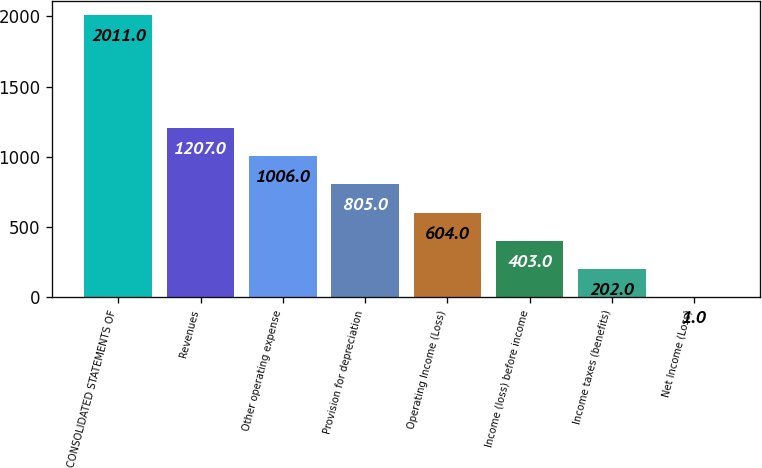Convert chart to OTSL. <chart><loc_0><loc_0><loc_500><loc_500><bar_chart><fcel>CONSOLIDATED STATEMENTS OF<fcel>Revenues<fcel>Other operating expense<fcel>Provision for depreciation<fcel>Operating Income (Loss)<fcel>Income (loss) before income<fcel>Income taxes (benefits)<fcel>Net Income (Loss)<nl><fcel>2011<fcel>1207<fcel>1006<fcel>805<fcel>604<fcel>403<fcel>202<fcel>1<nl></chart> 